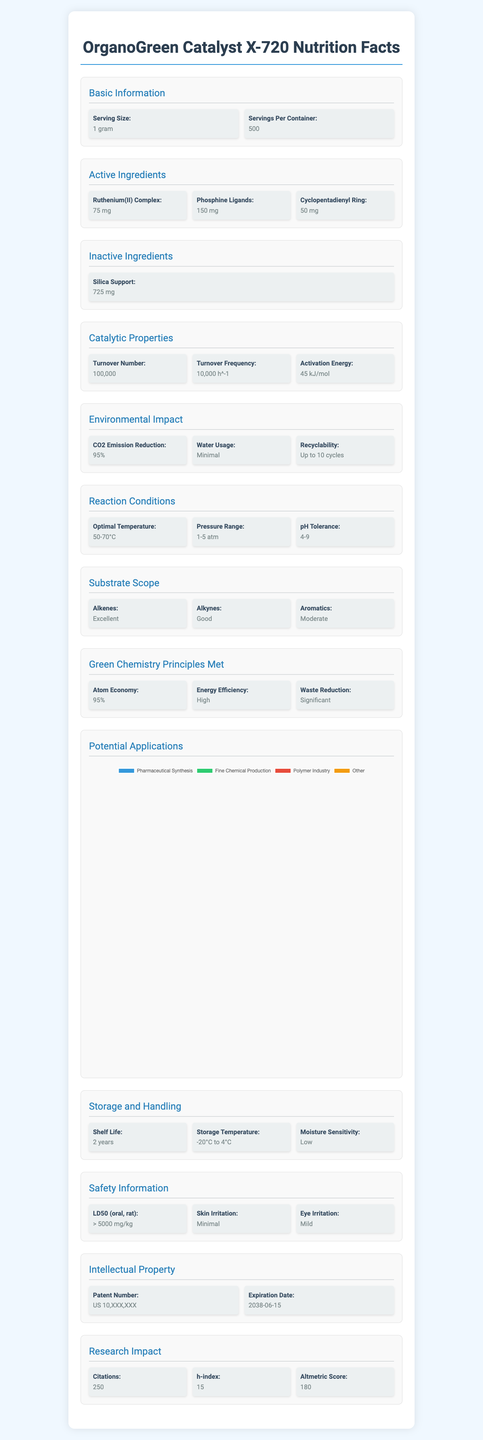What is the turnover number of OrganoGreen Catalyst X-720? The turnover number is listed under the section "Catalytic Properties" as 100,000.
Answer: 100,000 What are the active ingredients in OrganoGreen Catalyst X-720? The active ingredients are stated in the section "Active Ingredients" and include Ruthenium(II) Complex, Phosphine Ligands, and Cyclopentadienyl Ring.
Answer: Ruthenium(II) Complex, Phosphine Ligands, Cyclopentadienyl Ring How many grams of Ruthenium(II) Complex are there in one serving size? The amount of Ruthenium(II) Complex per serving size (1 gram) is 75 mg, as listed in the "Active Ingredients" section.
Answer: 75 mg What is the shelf life of OrganoGreen Catalyst X-720? The shelf life is detailed under the "Storage and Handling" section as 2 years.
Answer: 2 years What optimal temperature range is recommended for reactions utilizing OrganoGreen Catalyst X-720? The optimal temperature range is stated in the "Reaction Conditions" section as 50-70°C.
Answer: 50-70°C What is the efficiency of OrganoGreen Catalyst X-720 in reducing CO2 emissions? The efficiency in CO2 emission reduction is listed under the "Environmental Impact" section as 95%.
Answer: 95% Which of the following is NOT a potential application for OrganoGreen Catalyst X-720?
A. Pharmaceutical Synthesis  
B. Food Production  
C. Fine Chemical Production  
D. Polymer Industry The "Potential Applications" section lists Pharmaceutical Synthesis, Fine Chemical Production, and Polymer Industry, but not Food Production.
Answer: B What type of substrates does OrganoGreen Catalyst X-720 show excellent performance with?
A. Alkenes  
B. Alkynes  
C. Aromatics The "Substrate Scope" section explains that the catalyst performs excellently with Alkenes.
Answer: A True or False: OrganoGreen Catalyst X-720 can be recycled up to 20 cycles. The "Environmental Impact" section states that the recyclability is up to 10 cycles.
Answer: False Summarize the main features of OrganoGreen Catalyst X-720. The document discusses the catalyst's ingredients, catalytic properties, environmental impact, reaction conditions, substrate scope, and its potential applications. It also details safety information, storage and handling recommendations, and its intellectual property status.
Answer: OrganoGreen Catalyst X-720 is a novel organometallic catalyst that includes Ruthenium(II) Complex, Phosphine Ligands, and Cyclopentadienyl Ring as active ingredients. It has impressive catalytic properties with a turnover number of 100,000 and a turnover frequency of 10,000 h^-1. The catalyst excels in green chemistry principles like atom economy and CO2 emission reduction. It operates optimally at 50-70°C and 1-5 atm, and it can be recycled up to 10 times. Potential applications include pharmaceutical synthesis, fine chemical production, and the polymer industry. What is the patent number of OrganoGreen Catalyst X-720? The "Intellectual Property" section provides the patent number as US 10,XXX,XXX.
Answer: US 10,XXX,XXX What is the LD50 (oral, rat) for OrganoGreen Catalyst X-720? The LD50 is mentioned in the "Safety Information" section as greater than 5000 mg/kg.
Answer: > 5000 mg/kg How many citations does OrganoGreen Catalyst X-720 have? The "Research Impact" section states that the catalyst has 250 citations.
Answer: 250 What are some of the green chemistry principles met by OrganoGreen Catalyst X-720? The "Green Chemistry Principles Met" section lists Atom Economy, Energy Efficiency, and Waste Reduction.
Answer: Atom Economy (95%), Energy Efficiency (High), Waste Reduction (Significant) How much silica support is used in each gram serving of OrganoGreen Catalyst X-720? The "Inactive Ingredients" section states that there are 725 mg of silica support per gram.
Answer: 725 mg How does the turnover frequency of OrganoGreen Catalyst X-720 compare to traditional catalysts in this field? The document provides the turnover frequency of OrganoGreen Catalyst X-720 but does not provide comparative data with traditional catalysts.
Answer: Not enough information 